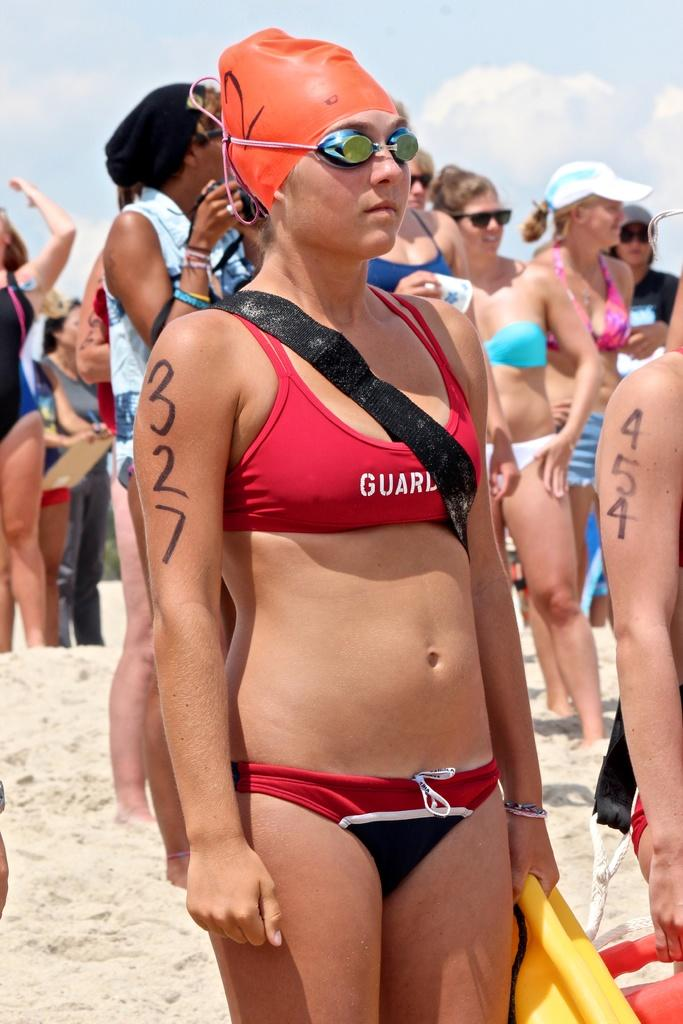<image>
Describe the image concisely. A female lifeguard an orange swim cap has the number 327 written on her arm and she is holding a yellow flotation device. 